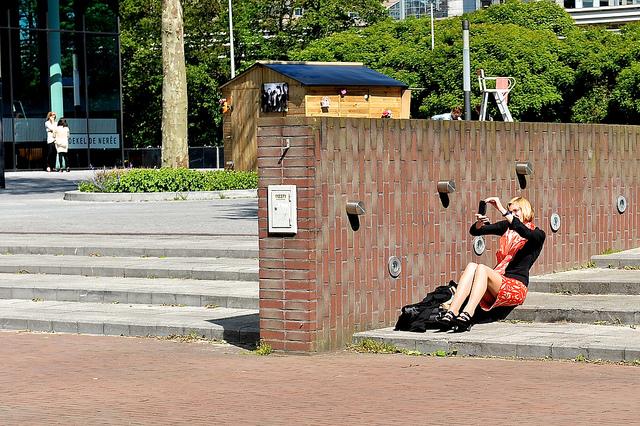What color is the woman's dress?
Short answer required. Red. Yes, it could be?
Keep it brief. No. Could this be a "selfie"?
Quick response, please. Yes. 